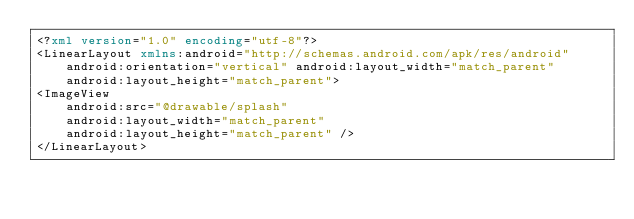<code> <loc_0><loc_0><loc_500><loc_500><_XML_><?xml version="1.0" encoding="utf-8"?>
<LinearLayout xmlns:android="http://schemas.android.com/apk/res/android"
    android:orientation="vertical" android:layout_width="match_parent"
    android:layout_height="match_parent">
<ImageView
    android:src="@drawable/splash"
    android:layout_width="match_parent"
    android:layout_height="match_parent" />
</LinearLayout></code> 